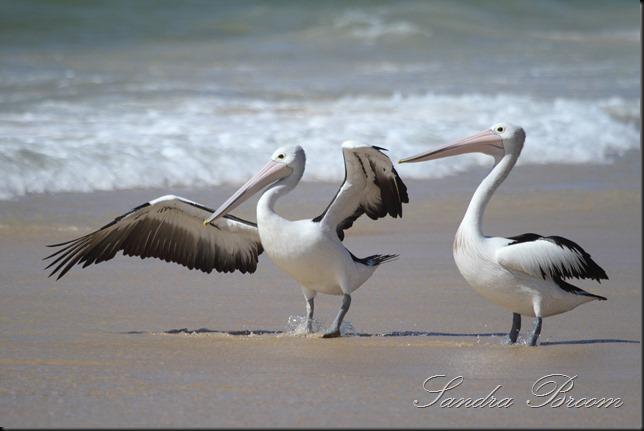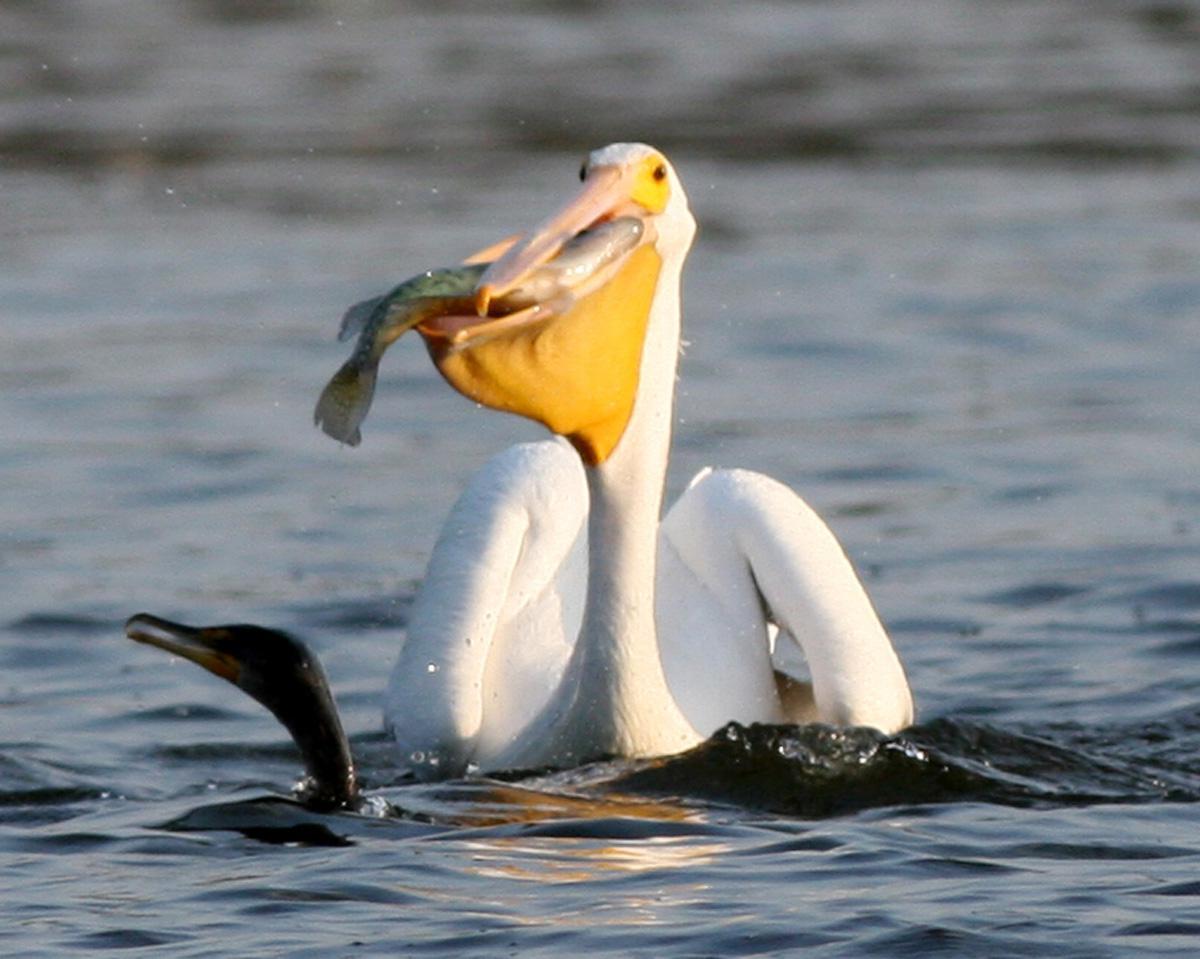The first image is the image on the left, the second image is the image on the right. For the images displayed, is the sentence "At least one of the birds has a fish in its mouth." factually correct? Answer yes or no. Yes. The first image is the image on the left, the second image is the image on the right. Assess this claim about the two images: "The bird in the right image is eating a fish.". Correct or not? Answer yes or no. Yes. 